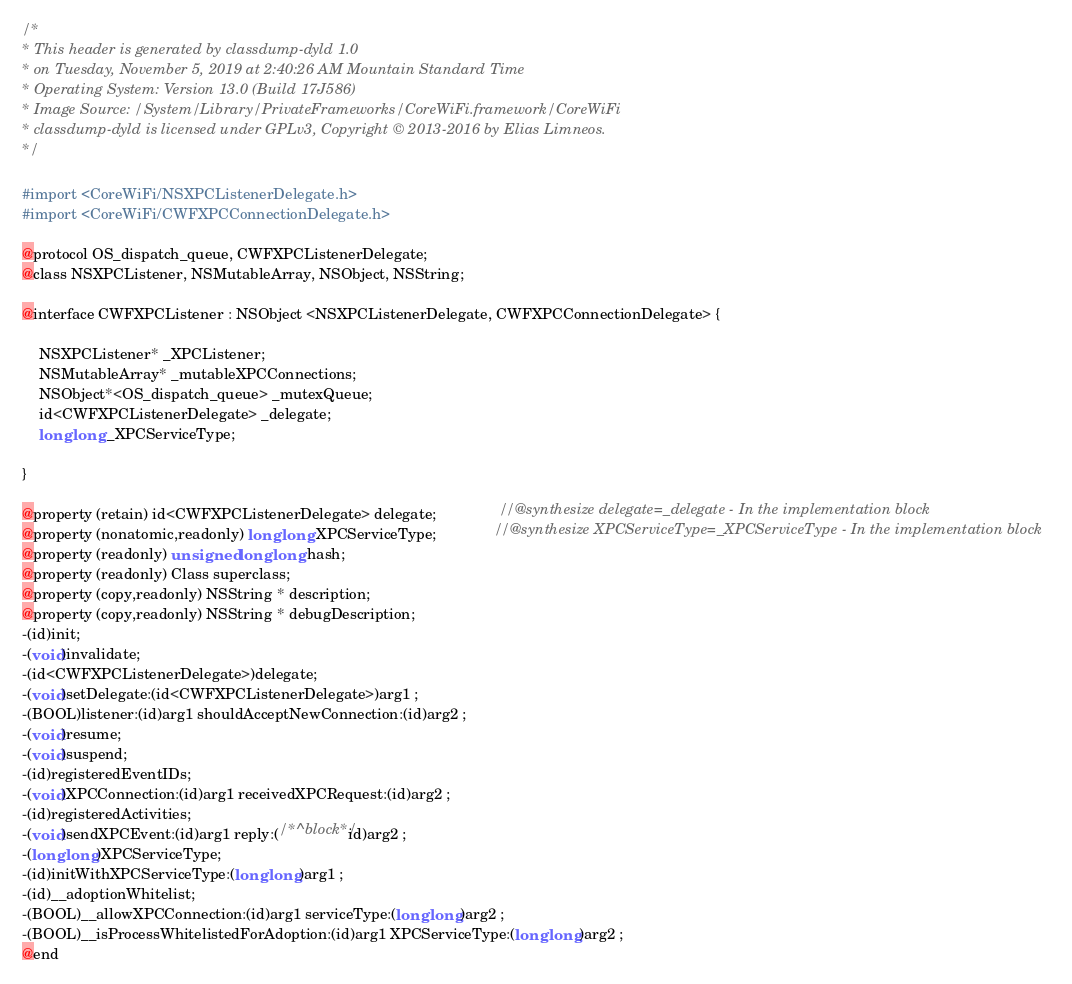Convert code to text. <code><loc_0><loc_0><loc_500><loc_500><_C_>/*
* This header is generated by classdump-dyld 1.0
* on Tuesday, November 5, 2019 at 2:40:26 AM Mountain Standard Time
* Operating System: Version 13.0 (Build 17J586)
* Image Source: /System/Library/PrivateFrameworks/CoreWiFi.framework/CoreWiFi
* classdump-dyld is licensed under GPLv3, Copyright © 2013-2016 by Elias Limneos.
*/

#import <CoreWiFi/NSXPCListenerDelegate.h>
#import <CoreWiFi/CWFXPCConnectionDelegate.h>

@protocol OS_dispatch_queue, CWFXPCListenerDelegate;
@class NSXPCListener, NSMutableArray, NSObject, NSString;

@interface CWFXPCListener : NSObject <NSXPCListenerDelegate, CWFXPCConnectionDelegate> {

	NSXPCListener* _XPCListener;
	NSMutableArray* _mutableXPCConnections;
	NSObject*<OS_dispatch_queue> _mutexQueue;
	id<CWFXPCListenerDelegate> _delegate;
	long long _XPCServiceType;

}

@property (retain) id<CWFXPCListenerDelegate> delegate;               //@synthesize delegate=_delegate - In the implementation block
@property (nonatomic,readonly) long long XPCServiceType;              //@synthesize XPCServiceType=_XPCServiceType - In the implementation block
@property (readonly) unsigned long long hash; 
@property (readonly) Class superclass; 
@property (copy,readonly) NSString * description; 
@property (copy,readonly) NSString * debugDescription; 
-(id)init;
-(void)invalidate;
-(id<CWFXPCListenerDelegate>)delegate;
-(void)setDelegate:(id<CWFXPCListenerDelegate>)arg1 ;
-(BOOL)listener:(id)arg1 shouldAcceptNewConnection:(id)arg2 ;
-(void)resume;
-(void)suspend;
-(id)registeredEventIDs;
-(void)XPCConnection:(id)arg1 receivedXPCRequest:(id)arg2 ;
-(id)registeredActivities;
-(void)sendXPCEvent:(id)arg1 reply:(/*^block*/id)arg2 ;
-(long long)XPCServiceType;
-(id)initWithXPCServiceType:(long long)arg1 ;
-(id)__adoptionWhitelist;
-(BOOL)__allowXPCConnection:(id)arg1 serviceType:(long long)arg2 ;
-(BOOL)__isProcessWhitelistedForAdoption:(id)arg1 XPCServiceType:(long long)arg2 ;
@end

</code> 